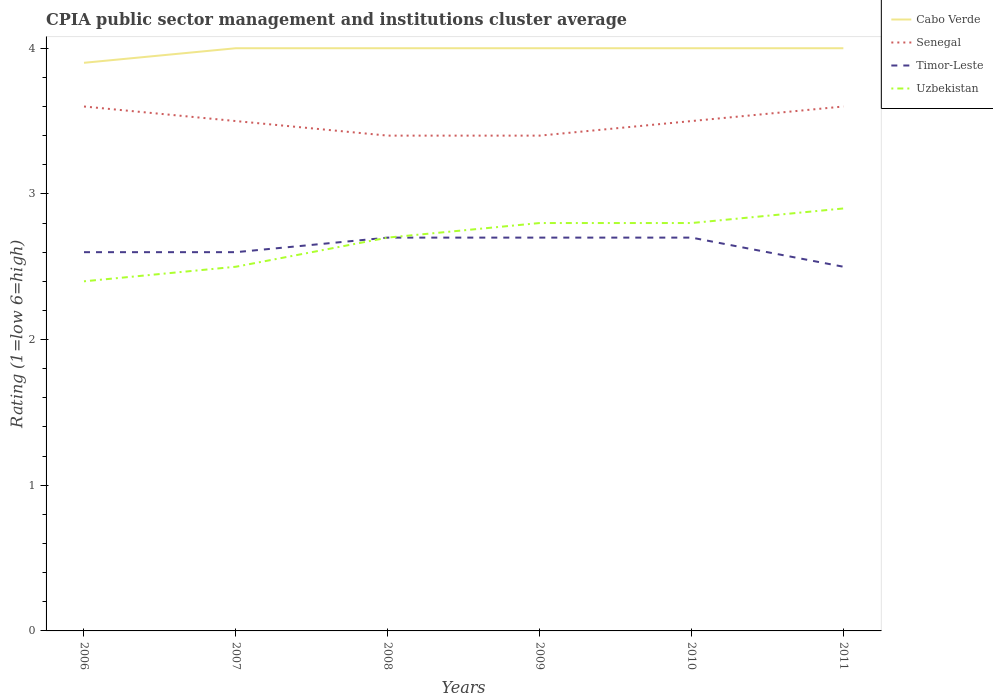Is the number of lines equal to the number of legend labels?
Your response must be concise. Yes. In which year was the CPIA rating in Senegal maximum?
Your response must be concise. 2008. What is the total CPIA rating in Cabo Verde in the graph?
Provide a short and direct response. -0.1. What is the difference between the highest and the lowest CPIA rating in Senegal?
Offer a terse response. 2. Is the CPIA rating in Uzbekistan strictly greater than the CPIA rating in Cabo Verde over the years?
Give a very brief answer. Yes. How many lines are there?
Provide a succinct answer. 4. How many years are there in the graph?
Give a very brief answer. 6. Are the values on the major ticks of Y-axis written in scientific E-notation?
Keep it short and to the point. No. Does the graph contain grids?
Your answer should be compact. No. How are the legend labels stacked?
Your answer should be very brief. Vertical. What is the title of the graph?
Ensure brevity in your answer.  CPIA public sector management and institutions cluster average. Does "Oman" appear as one of the legend labels in the graph?
Your answer should be compact. No. What is the label or title of the X-axis?
Keep it short and to the point. Years. What is the label or title of the Y-axis?
Make the answer very short. Rating (1=low 6=high). What is the Rating (1=low 6=high) in Senegal in 2007?
Your response must be concise. 3.5. What is the Rating (1=low 6=high) of Uzbekistan in 2007?
Your answer should be very brief. 2.5. What is the Rating (1=low 6=high) in Senegal in 2008?
Give a very brief answer. 3.4. What is the Rating (1=low 6=high) of Timor-Leste in 2008?
Give a very brief answer. 2.7. What is the Rating (1=low 6=high) in Uzbekistan in 2009?
Ensure brevity in your answer.  2.8. What is the Rating (1=low 6=high) in Senegal in 2010?
Give a very brief answer. 3.5. What is the Rating (1=low 6=high) of Timor-Leste in 2010?
Your answer should be compact. 2.7. What is the Rating (1=low 6=high) in Senegal in 2011?
Your answer should be very brief. 3.6. What is the Rating (1=low 6=high) of Timor-Leste in 2011?
Your answer should be compact. 2.5. What is the Rating (1=low 6=high) in Uzbekistan in 2011?
Your answer should be compact. 2.9. Across all years, what is the maximum Rating (1=low 6=high) of Cabo Verde?
Make the answer very short. 4. Across all years, what is the maximum Rating (1=low 6=high) in Senegal?
Provide a short and direct response. 3.6. Across all years, what is the minimum Rating (1=low 6=high) of Cabo Verde?
Your answer should be compact. 3.9. Across all years, what is the minimum Rating (1=low 6=high) of Senegal?
Your answer should be very brief. 3.4. Across all years, what is the minimum Rating (1=low 6=high) of Timor-Leste?
Offer a terse response. 2.5. Across all years, what is the minimum Rating (1=low 6=high) in Uzbekistan?
Ensure brevity in your answer.  2.4. What is the total Rating (1=low 6=high) of Cabo Verde in the graph?
Offer a terse response. 23.9. What is the total Rating (1=low 6=high) of Timor-Leste in the graph?
Provide a succinct answer. 15.8. What is the total Rating (1=low 6=high) of Uzbekistan in the graph?
Your answer should be very brief. 16.1. What is the difference between the Rating (1=low 6=high) of Cabo Verde in 2006 and that in 2007?
Provide a short and direct response. -0.1. What is the difference between the Rating (1=low 6=high) of Timor-Leste in 2006 and that in 2007?
Provide a short and direct response. 0. What is the difference between the Rating (1=low 6=high) of Uzbekistan in 2006 and that in 2007?
Offer a very short reply. -0.1. What is the difference between the Rating (1=low 6=high) in Senegal in 2006 and that in 2008?
Keep it short and to the point. 0.2. What is the difference between the Rating (1=low 6=high) of Timor-Leste in 2006 and that in 2008?
Keep it short and to the point. -0.1. What is the difference between the Rating (1=low 6=high) of Timor-Leste in 2006 and that in 2009?
Provide a succinct answer. -0.1. What is the difference between the Rating (1=low 6=high) in Timor-Leste in 2006 and that in 2010?
Ensure brevity in your answer.  -0.1. What is the difference between the Rating (1=low 6=high) of Uzbekistan in 2006 and that in 2010?
Give a very brief answer. -0.4. What is the difference between the Rating (1=low 6=high) in Senegal in 2006 and that in 2011?
Offer a very short reply. 0. What is the difference between the Rating (1=low 6=high) in Timor-Leste in 2006 and that in 2011?
Give a very brief answer. 0.1. What is the difference between the Rating (1=low 6=high) of Uzbekistan in 2006 and that in 2011?
Your answer should be compact. -0.5. What is the difference between the Rating (1=low 6=high) of Cabo Verde in 2007 and that in 2008?
Your answer should be very brief. 0. What is the difference between the Rating (1=low 6=high) of Timor-Leste in 2007 and that in 2008?
Provide a short and direct response. -0.1. What is the difference between the Rating (1=low 6=high) of Cabo Verde in 2007 and that in 2009?
Offer a very short reply. 0. What is the difference between the Rating (1=low 6=high) of Senegal in 2007 and that in 2009?
Your answer should be very brief. 0.1. What is the difference between the Rating (1=low 6=high) of Uzbekistan in 2007 and that in 2009?
Your response must be concise. -0.3. What is the difference between the Rating (1=low 6=high) of Senegal in 2007 and that in 2010?
Your answer should be compact. 0. What is the difference between the Rating (1=low 6=high) of Timor-Leste in 2007 and that in 2010?
Offer a terse response. -0.1. What is the difference between the Rating (1=low 6=high) of Senegal in 2007 and that in 2011?
Your response must be concise. -0.1. What is the difference between the Rating (1=low 6=high) in Timor-Leste in 2007 and that in 2011?
Offer a terse response. 0.1. What is the difference between the Rating (1=low 6=high) in Cabo Verde in 2008 and that in 2009?
Ensure brevity in your answer.  0. What is the difference between the Rating (1=low 6=high) of Uzbekistan in 2008 and that in 2009?
Offer a very short reply. -0.1. What is the difference between the Rating (1=low 6=high) of Cabo Verde in 2008 and that in 2010?
Provide a succinct answer. 0. What is the difference between the Rating (1=low 6=high) of Senegal in 2008 and that in 2010?
Make the answer very short. -0.1. What is the difference between the Rating (1=low 6=high) in Timor-Leste in 2008 and that in 2010?
Make the answer very short. 0. What is the difference between the Rating (1=low 6=high) in Uzbekistan in 2008 and that in 2010?
Your response must be concise. -0.1. What is the difference between the Rating (1=low 6=high) in Uzbekistan in 2008 and that in 2011?
Offer a very short reply. -0.2. What is the difference between the Rating (1=low 6=high) in Cabo Verde in 2009 and that in 2010?
Provide a succinct answer. 0. What is the difference between the Rating (1=low 6=high) of Timor-Leste in 2009 and that in 2010?
Your response must be concise. 0. What is the difference between the Rating (1=low 6=high) in Cabo Verde in 2009 and that in 2011?
Keep it short and to the point. 0. What is the difference between the Rating (1=low 6=high) of Timor-Leste in 2009 and that in 2011?
Offer a very short reply. 0.2. What is the difference between the Rating (1=low 6=high) of Cabo Verde in 2010 and that in 2011?
Offer a very short reply. 0. What is the difference between the Rating (1=low 6=high) in Senegal in 2010 and that in 2011?
Keep it short and to the point. -0.1. What is the difference between the Rating (1=low 6=high) in Timor-Leste in 2010 and that in 2011?
Offer a very short reply. 0.2. What is the difference between the Rating (1=low 6=high) of Cabo Verde in 2006 and the Rating (1=low 6=high) of Timor-Leste in 2007?
Your response must be concise. 1.3. What is the difference between the Rating (1=low 6=high) in Timor-Leste in 2006 and the Rating (1=low 6=high) in Uzbekistan in 2007?
Offer a very short reply. 0.1. What is the difference between the Rating (1=low 6=high) in Cabo Verde in 2006 and the Rating (1=low 6=high) in Senegal in 2008?
Offer a very short reply. 0.5. What is the difference between the Rating (1=low 6=high) in Senegal in 2006 and the Rating (1=low 6=high) in Timor-Leste in 2008?
Offer a terse response. 0.9. What is the difference between the Rating (1=low 6=high) in Senegal in 2006 and the Rating (1=low 6=high) in Uzbekistan in 2008?
Make the answer very short. 0.9. What is the difference between the Rating (1=low 6=high) in Timor-Leste in 2006 and the Rating (1=low 6=high) in Uzbekistan in 2008?
Offer a terse response. -0.1. What is the difference between the Rating (1=low 6=high) in Cabo Verde in 2006 and the Rating (1=low 6=high) in Timor-Leste in 2009?
Give a very brief answer. 1.2. What is the difference between the Rating (1=low 6=high) in Cabo Verde in 2006 and the Rating (1=low 6=high) in Uzbekistan in 2009?
Ensure brevity in your answer.  1.1. What is the difference between the Rating (1=low 6=high) in Timor-Leste in 2006 and the Rating (1=low 6=high) in Uzbekistan in 2009?
Your response must be concise. -0.2. What is the difference between the Rating (1=low 6=high) in Senegal in 2006 and the Rating (1=low 6=high) in Uzbekistan in 2010?
Provide a short and direct response. 0.8. What is the difference between the Rating (1=low 6=high) in Cabo Verde in 2006 and the Rating (1=low 6=high) in Senegal in 2011?
Make the answer very short. 0.3. What is the difference between the Rating (1=low 6=high) in Cabo Verde in 2006 and the Rating (1=low 6=high) in Timor-Leste in 2011?
Provide a short and direct response. 1.4. What is the difference between the Rating (1=low 6=high) of Cabo Verde in 2007 and the Rating (1=low 6=high) of Senegal in 2008?
Your answer should be compact. 0.6. What is the difference between the Rating (1=low 6=high) in Cabo Verde in 2007 and the Rating (1=low 6=high) in Timor-Leste in 2008?
Your answer should be very brief. 1.3. What is the difference between the Rating (1=low 6=high) in Senegal in 2007 and the Rating (1=low 6=high) in Timor-Leste in 2008?
Provide a short and direct response. 0.8. What is the difference between the Rating (1=low 6=high) of Timor-Leste in 2007 and the Rating (1=low 6=high) of Uzbekistan in 2009?
Keep it short and to the point. -0.2. What is the difference between the Rating (1=low 6=high) in Cabo Verde in 2007 and the Rating (1=low 6=high) in Senegal in 2010?
Offer a terse response. 0.5. What is the difference between the Rating (1=low 6=high) of Senegal in 2007 and the Rating (1=low 6=high) of Timor-Leste in 2010?
Keep it short and to the point. 0.8. What is the difference between the Rating (1=low 6=high) in Senegal in 2007 and the Rating (1=low 6=high) in Uzbekistan in 2010?
Offer a very short reply. 0.7. What is the difference between the Rating (1=low 6=high) of Cabo Verde in 2007 and the Rating (1=low 6=high) of Senegal in 2011?
Provide a short and direct response. 0.4. What is the difference between the Rating (1=low 6=high) in Cabo Verde in 2007 and the Rating (1=low 6=high) in Timor-Leste in 2011?
Your response must be concise. 1.5. What is the difference between the Rating (1=low 6=high) of Cabo Verde in 2007 and the Rating (1=low 6=high) of Uzbekistan in 2011?
Provide a short and direct response. 1.1. What is the difference between the Rating (1=low 6=high) in Senegal in 2007 and the Rating (1=low 6=high) in Timor-Leste in 2011?
Keep it short and to the point. 1. What is the difference between the Rating (1=low 6=high) in Senegal in 2007 and the Rating (1=low 6=high) in Uzbekistan in 2011?
Ensure brevity in your answer.  0.6. What is the difference between the Rating (1=low 6=high) in Cabo Verde in 2008 and the Rating (1=low 6=high) in Senegal in 2009?
Provide a short and direct response. 0.6. What is the difference between the Rating (1=low 6=high) in Senegal in 2008 and the Rating (1=low 6=high) in Timor-Leste in 2009?
Provide a succinct answer. 0.7. What is the difference between the Rating (1=low 6=high) in Cabo Verde in 2008 and the Rating (1=low 6=high) in Senegal in 2010?
Your answer should be very brief. 0.5. What is the difference between the Rating (1=low 6=high) in Cabo Verde in 2008 and the Rating (1=low 6=high) in Timor-Leste in 2010?
Your answer should be very brief. 1.3. What is the difference between the Rating (1=low 6=high) of Senegal in 2008 and the Rating (1=low 6=high) of Uzbekistan in 2010?
Your response must be concise. 0.6. What is the difference between the Rating (1=low 6=high) in Timor-Leste in 2008 and the Rating (1=low 6=high) in Uzbekistan in 2010?
Ensure brevity in your answer.  -0.1. What is the difference between the Rating (1=low 6=high) of Cabo Verde in 2008 and the Rating (1=low 6=high) of Senegal in 2011?
Provide a succinct answer. 0.4. What is the difference between the Rating (1=low 6=high) of Cabo Verde in 2008 and the Rating (1=low 6=high) of Uzbekistan in 2011?
Keep it short and to the point. 1.1. What is the difference between the Rating (1=low 6=high) of Senegal in 2008 and the Rating (1=low 6=high) of Timor-Leste in 2011?
Make the answer very short. 0.9. What is the difference between the Rating (1=low 6=high) in Senegal in 2008 and the Rating (1=low 6=high) in Uzbekistan in 2011?
Your answer should be very brief. 0.5. What is the difference between the Rating (1=low 6=high) in Timor-Leste in 2008 and the Rating (1=low 6=high) in Uzbekistan in 2011?
Offer a terse response. -0.2. What is the difference between the Rating (1=low 6=high) in Cabo Verde in 2009 and the Rating (1=low 6=high) in Timor-Leste in 2010?
Provide a succinct answer. 1.3. What is the difference between the Rating (1=low 6=high) of Cabo Verde in 2009 and the Rating (1=low 6=high) of Uzbekistan in 2010?
Give a very brief answer. 1.2. What is the difference between the Rating (1=low 6=high) of Senegal in 2009 and the Rating (1=low 6=high) of Timor-Leste in 2010?
Your answer should be compact. 0.7. What is the difference between the Rating (1=low 6=high) of Senegal in 2009 and the Rating (1=low 6=high) of Uzbekistan in 2010?
Your answer should be very brief. 0.6. What is the difference between the Rating (1=low 6=high) in Cabo Verde in 2009 and the Rating (1=low 6=high) in Senegal in 2011?
Provide a short and direct response. 0.4. What is the difference between the Rating (1=low 6=high) in Senegal in 2009 and the Rating (1=low 6=high) in Uzbekistan in 2011?
Offer a very short reply. 0.5. What is the difference between the Rating (1=low 6=high) of Timor-Leste in 2009 and the Rating (1=low 6=high) of Uzbekistan in 2011?
Provide a short and direct response. -0.2. What is the difference between the Rating (1=low 6=high) of Cabo Verde in 2010 and the Rating (1=low 6=high) of Senegal in 2011?
Your answer should be compact. 0.4. What is the difference between the Rating (1=low 6=high) in Cabo Verde in 2010 and the Rating (1=low 6=high) in Uzbekistan in 2011?
Provide a succinct answer. 1.1. What is the difference between the Rating (1=low 6=high) in Senegal in 2010 and the Rating (1=low 6=high) in Uzbekistan in 2011?
Provide a succinct answer. 0.6. What is the difference between the Rating (1=low 6=high) in Timor-Leste in 2010 and the Rating (1=low 6=high) in Uzbekistan in 2011?
Ensure brevity in your answer.  -0.2. What is the average Rating (1=low 6=high) of Cabo Verde per year?
Offer a very short reply. 3.98. What is the average Rating (1=low 6=high) of Timor-Leste per year?
Your answer should be very brief. 2.63. What is the average Rating (1=low 6=high) in Uzbekistan per year?
Your answer should be compact. 2.68. In the year 2006, what is the difference between the Rating (1=low 6=high) in Cabo Verde and Rating (1=low 6=high) in Senegal?
Provide a short and direct response. 0.3. In the year 2006, what is the difference between the Rating (1=low 6=high) in Senegal and Rating (1=low 6=high) in Timor-Leste?
Make the answer very short. 1. In the year 2006, what is the difference between the Rating (1=low 6=high) of Senegal and Rating (1=low 6=high) of Uzbekistan?
Give a very brief answer. 1.2. In the year 2006, what is the difference between the Rating (1=low 6=high) of Timor-Leste and Rating (1=low 6=high) of Uzbekistan?
Offer a very short reply. 0.2. In the year 2007, what is the difference between the Rating (1=low 6=high) of Cabo Verde and Rating (1=low 6=high) of Senegal?
Provide a short and direct response. 0.5. In the year 2007, what is the difference between the Rating (1=low 6=high) of Cabo Verde and Rating (1=low 6=high) of Timor-Leste?
Give a very brief answer. 1.4. In the year 2007, what is the difference between the Rating (1=low 6=high) in Cabo Verde and Rating (1=low 6=high) in Uzbekistan?
Give a very brief answer. 1.5. In the year 2007, what is the difference between the Rating (1=low 6=high) of Senegal and Rating (1=low 6=high) of Timor-Leste?
Keep it short and to the point. 0.9. In the year 2008, what is the difference between the Rating (1=low 6=high) in Cabo Verde and Rating (1=low 6=high) in Senegal?
Your response must be concise. 0.6. In the year 2009, what is the difference between the Rating (1=low 6=high) of Cabo Verde and Rating (1=low 6=high) of Senegal?
Give a very brief answer. 0.6. In the year 2009, what is the difference between the Rating (1=low 6=high) of Cabo Verde and Rating (1=low 6=high) of Timor-Leste?
Provide a succinct answer. 1.3. In the year 2009, what is the difference between the Rating (1=low 6=high) in Cabo Verde and Rating (1=low 6=high) in Uzbekistan?
Your response must be concise. 1.2. In the year 2009, what is the difference between the Rating (1=low 6=high) in Timor-Leste and Rating (1=low 6=high) in Uzbekistan?
Provide a short and direct response. -0.1. In the year 2010, what is the difference between the Rating (1=low 6=high) of Cabo Verde and Rating (1=low 6=high) of Senegal?
Provide a short and direct response. 0.5. In the year 2010, what is the difference between the Rating (1=low 6=high) in Cabo Verde and Rating (1=low 6=high) in Uzbekistan?
Provide a short and direct response. 1.2. In the year 2010, what is the difference between the Rating (1=low 6=high) in Senegal and Rating (1=low 6=high) in Timor-Leste?
Give a very brief answer. 0.8. In the year 2010, what is the difference between the Rating (1=low 6=high) in Timor-Leste and Rating (1=low 6=high) in Uzbekistan?
Keep it short and to the point. -0.1. In the year 2011, what is the difference between the Rating (1=low 6=high) of Cabo Verde and Rating (1=low 6=high) of Timor-Leste?
Provide a succinct answer. 1.5. In the year 2011, what is the difference between the Rating (1=low 6=high) of Cabo Verde and Rating (1=low 6=high) of Uzbekistan?
Offer a terse response. 1.1. In the year 2011, what is the difference between the Rating (1=low 6=high) in Senegal and Rating (1=low 6=high) in Timor-Leste?
Ensure brevity in your answer.  1.1. What is the ratio of the Rating (1=low 6=high) of Senegal in 2006 to that in 2007?
Your answer should be very brief. 1.03. What is the ratio of the Rating (1=low 6=high) in Cabo Verde in 2006 to that in 2008?
Provide a succinct answer. 0.97. What is the ratio of the Rating (1=low 6=high) in Senegal in 2006 to that in 2008?
Your answer should be compact. 1.06. What is the ratio of the Rating (1=low 6=high) in Senegal in 2006 to that in 2009?
Provide a succinct answer. 1.06. What is the ratio of the Rating (1=low 6=high) in Timor-Leste in 2006 to that in 2009?
Your response must be concise. 0.96. What is the ratio of the Rating (1=low 6=high) of Uzbekistan in 2006 to that in 2009?
Make the answer very short. 0.86. What is the ratio of the Rating (1=low 6=high) in Cabo Verde in 2006 to that in 2010?
Keep it short and to the point. 0.97. What is the ratio of the Rating (1=low 6=high) of Senegal in 2006 to that in 2010?
Your response must be concise. 1.03. What is the ratio of the Rating (1=low 6=high) of Timor-Leste in 2006 to that in 2010?
Give a very brief answer. 0.96. What is the ratio of the Rating (1=low 6=high) of Uzbekistan in 2006 to that in 2010?
Offer a very short reply. 0.86. What is the ratio of the Rating (1=low 6=high) of Uzbekistan in 2006 to that in 2011?
Keep it short and to the point. 0.83. What is the ratio of the Rating (1=low 6=high) of Senegal in 2007 to that in 2008?
Give a very brief answer. 1.03. What is the ratio of the Rating (1=low 6=high) of Uzbekistan in 2007 to that in 2008?
Provide a short and direct response. 0.93. What is the ratio of the Rating (1=low 6=high) of Cabo Verde in 2007 to that in 2009?
Your response must be concise. 1. What is the ratio of the Rating (1=low 6=high) of Senegal in 2007 to that in 2009?
Ensure brevity in your answer.  1.03. What is the ratio of the Rating (1=low 6=high) of Timor-Leste in 2007 to that in 2009?
Keep it short and to the point. 0.96. What is the ratio of the Rating (1=low 6=high) in Uzbekistan in 2007 to that in 2009?
Make the answer very short. 0.89. What is the ratio of the Rating (1=low 6=high) of Cabo Verde in 2007 to that in 2010?
Give a very brief answer. 1. What is the ratio of the Rating (1=low 6=high) in Uzbekistan in 2007 to that in 2010?
Provide a short and direct response. 0.89. What is the ratio of the Rating (1=low 6=high) in Senegal in 2007 to that in 2011?
Offer a very short reply. 0.97. What is the ratio of the Rating (1=low 6=high) in Timor-Leste in 2007 to that in 2011?
Provide a succinct answer. 1.04. What is the ratio of the Rating (1=low 6=high) of Uzbekistan in 2007 to that in 2011?
Make the answer very short. 0.86. What is the ratio of the Rating (1=low 6=high) of Senegal in 2008 to that in 2009?
Offer a terse response. 1. What is the ratio of the Rating (1=low 6=high) in Timor-Leste in 2008 to that in 2009?
Ensure brevity in your answer.  1. What is the ratio of the Rating (1=low 6=high) in Cabo Verde in 2008 to that in 2010?
Your response must be concise. 1. What is the ratio of the Rating (1=low 6=high) of Senegal in 2008 to that in 2010?
Keep it short and to the point. 0.97. What is the ratio of the Rating (1=low 6=high) in Uzbekistan in 2008 to that in 2010?
Your response must be concise. 0.96. What is the ratio of the Rating (1=low 6=high) of Timor-Leste in 2008 to that in 2011?
Ensure brevity in your answer.  1.08. What is the ratio of the Rating (1=low 6=high) of Senegal in 2009 to that in 2010?
Provide a succinct answer. 0.97. What is the ratio of the Rating (1=low 6=high) of Timor-Leste in 2009 to that in 2010?
Your answer should be very brief. 1. What is the ratio of the Rating (1=low 6=high) of Uzbekistan in 2009 to that in 2010?
Make the answer very short. 1. What is the ratio of the Rating (1=low 6=high) of Senegal in 2009 to that in 2011?
Make the answer very short. 0.94. What is the ratio of the Rating (1=low 6=high) in Timor-Leste in 2009 to that in 2011?
Your answer should be very brief. 1.08. What is the ratio of the Rating (1=low 6=high) of Uzbekistan in 2009 to that in 2011?
Your answer should be compact. 0.97. What is the ratio of the Rating (1=low 6=high) of Cabo Verde in 2010 to that in 2011?
Your answer should be compact. 1. What is the ratio of the Rating (1=low 6=high) of Senegal in 2010 to that in 2011?
Provide a succinct answer. 0.97. What is the ratio of the Rating (1=low 6=high) in Timor-Leste in 2010 to that in 2011?
Offer a very short reply. 1.08. What is the ratio of the Rating (1=low 6=high) of Uzbekistan in 2010 to that in 2011?
Offer a terse response. 0.97. What is the difference between the highest and the second highest Rating (1=low 6=high) of Senegal?
Your response must be concise. 0. What is the difference between the highest and the second highest Rating (1=low 6=high) in Timor-Leste?
Provide a short and direct response. 0. What is the difference between the highest and the second highest Rating (1=low 6=high) in Uzbekistan?
Ensure brevity in your answer.  0.1. What is the difference between the highest and the lowest Rating (1=low 6=high) in Senegal?
Keep it short and to the point. 0.2. What is the difference between the highest and the lowest Rating (1=low 6=high) in Timor-Leste?
Make the answer very short. 0.2. 